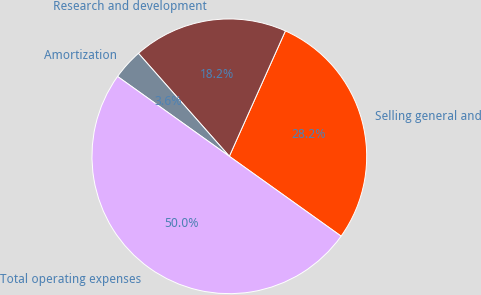<chart> <loc_0><loc_0><loc_500><loc_500><pie_chart><fcel>Selling general and<fcel>Research and development<fcel>Amortization<fcel>Total operating expenses<nl><fcel>28.18%<fcel>18.2%<fcel>3.62%<fcel>50.0%<nl></chart> 